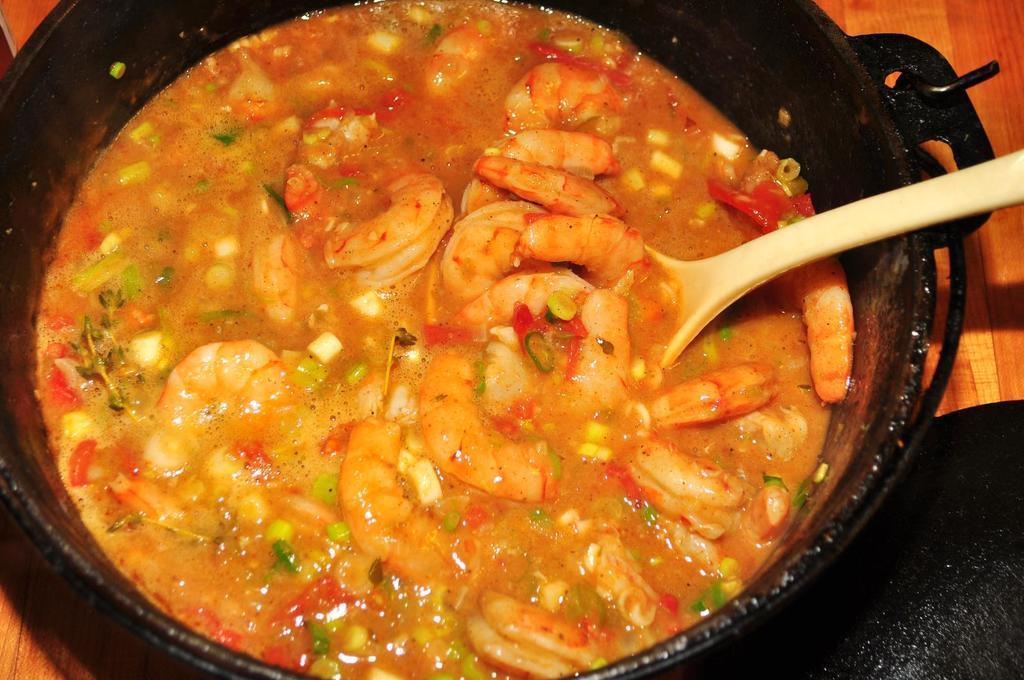How would you summarize this image in a sentence or two? In this image I can see it looks like a curry in a black color bowl. There is a white color spoon it. 